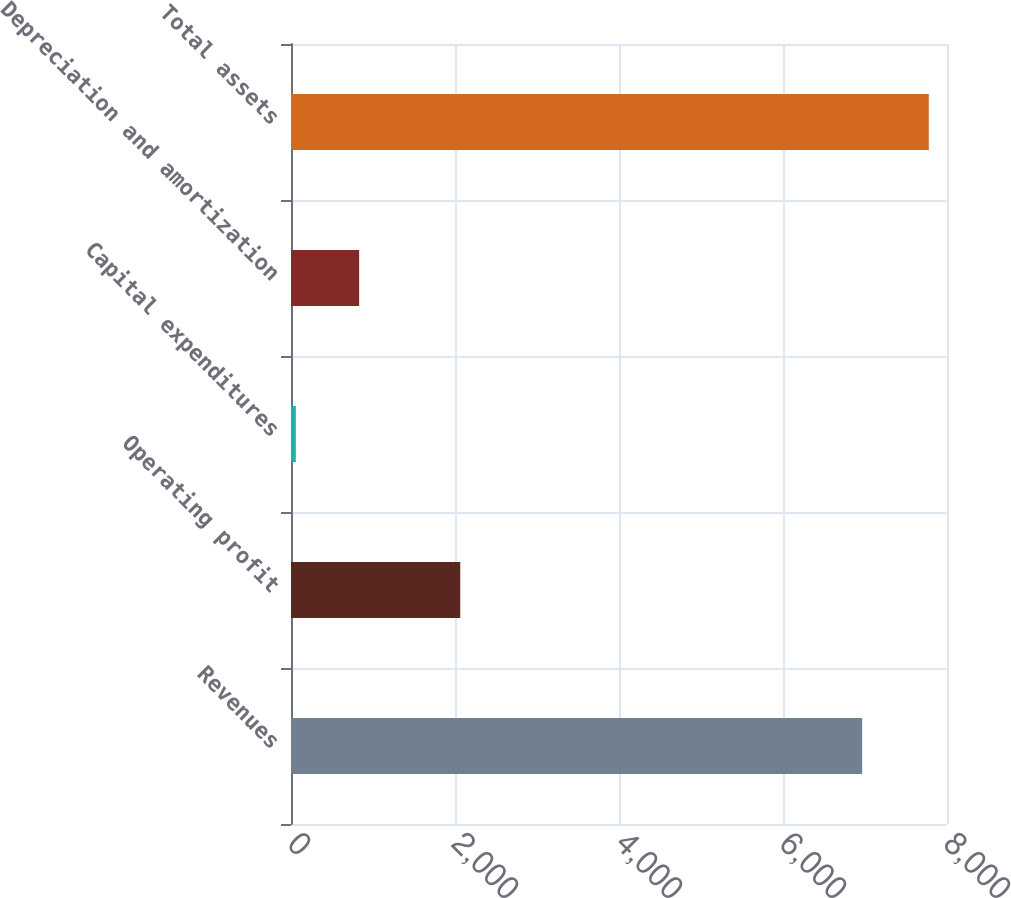Convert chart to OTSL. <chart><loc_0><loc_0><loc_500><loc_500><bar_chart><fcel>Revenues<fcel>Operating profit<fcel>Capital expenditures<fcel>Depreciation and amortization<fcel>Total assets<nl><fcel>6965<fcel>2064<fcel>59<fcel>830.9<fcel>7778<nl></chart> 